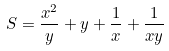<formula> <loc_0><loc_0><loc_500><loc_500>S = \frac { x ^ { 2 } } { y } + y + \frac { 1 } { x } + \frac { 1 } { x y }</formula> 